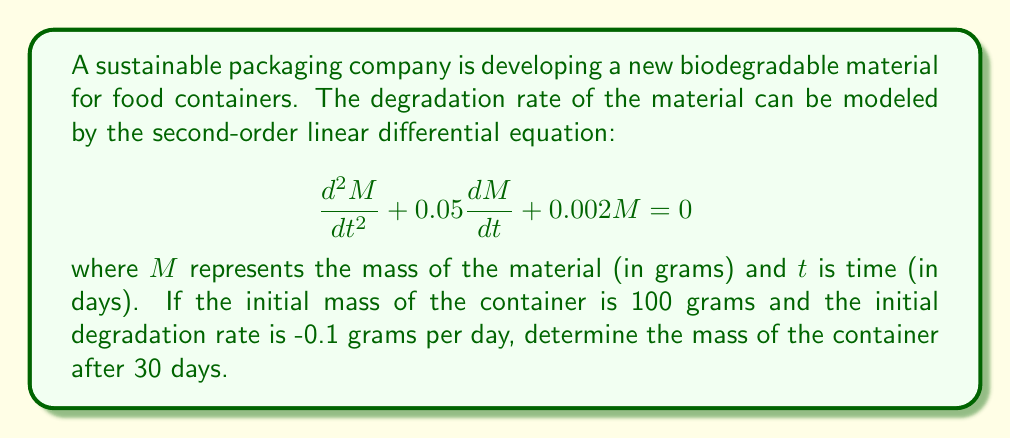Solve this math problem. To solve this problem, we need to follow these steps:

1) First, we need to find the general solution of the given differential equation. The characteristic equation is:

   $$r^2 + 0.05r + 0.002 = 0$$

2) Solving this quadratic equation:

   $$r = \frac{-0.05 \pm \sqrt{0.05^2 - 4(1)(0.002)}}{2(1)} = \frac{-0.05 \pm \sqrt{0.0025 - 0.008}}{2} = \frac{-0.05 \pm \sqrt{-0.0055}}{2}$$

3) This gives us complex roots:

   $$r = -0.025 \pm 0.037i$$

4) Therefore, the general solution is:

   $$M(t) = e^{-0.025t}(C_1\cos(0.037t) + C_2\sin(0.037t))$$

5) Now we use the initial conditions to find $C_1$ and $C_2$:
   
   At $t=0$, $M(0) = 100$, so:
   $$100 = C_1$$

   The initial rate is $M'(0) = -0.1$, so:
   $$-0.1 = -0.025C_1 + 0.037C_2$$
   $$-0.1 = -2.5 + 0.037C_2$$
   $$C_2 = \frac{2.4}{0.037} \approx 64.86$$

6) Our particular solution is:

   $$M(t) = e^{-0.025t}(100\cos(0.037t) + 64.86\sin(0.037t))$$

7) To find the mass after 30 days, we plug in $t=30$:

   $$M(30) = e^{-0.025(30)}(100\cos(0.037(30)) + 64.86\sin(0.037(30)))$$

8) Calculating this gives us approximately 92.76 grams.
Answer: The mass of the container after 30 days is approximately 92.76 grams. 